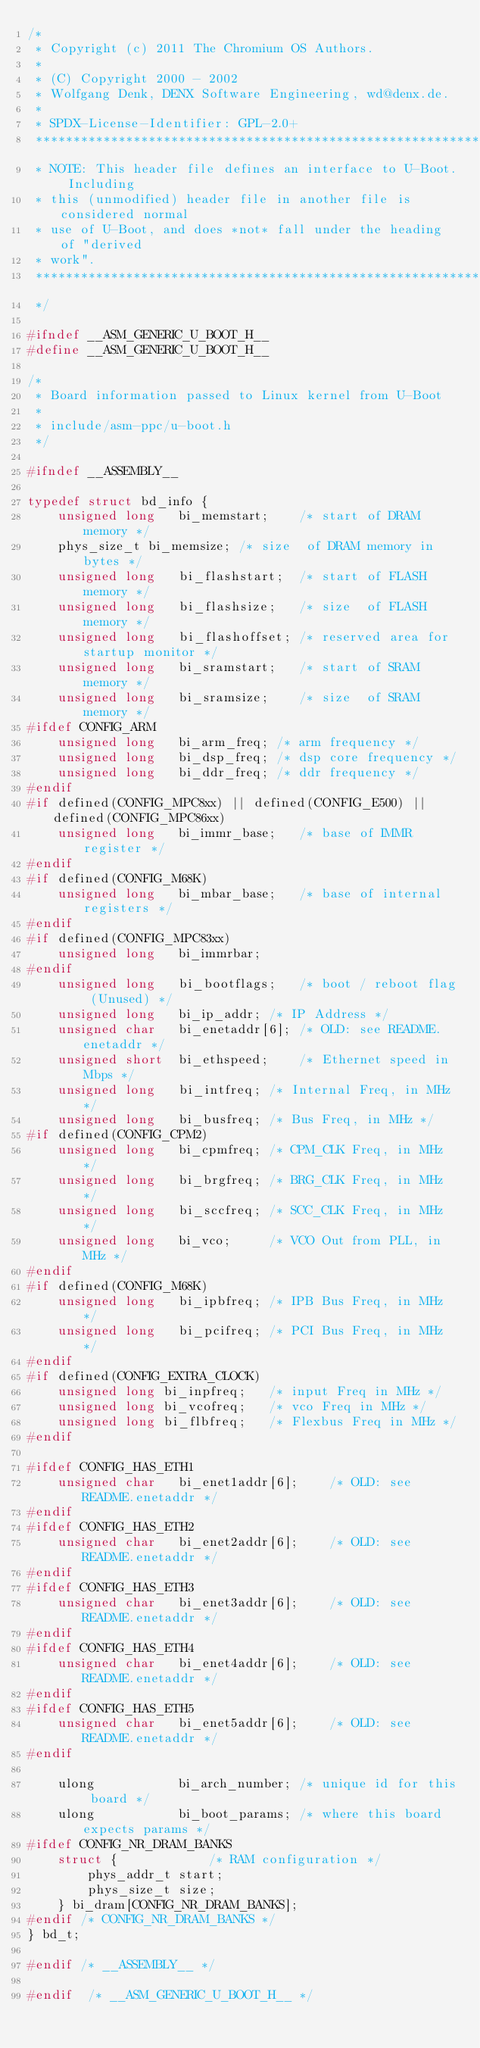<code> <loc_0><loc_0><loc_500><loc_500><_C_>/*
 * Copyright (c) 2011 The Chromium OS Authors.
 *
 * (C) Copyright 2000 - 2002
 * Wolfgang Denk, DENX Software Engineering, wd@denx.de.
 *
 * SPDX-License-Identifier:	GPL-2.0+
 ********************************************************************
 * NOTE: This header file defines an interface to U-Boot. Including
 * this (unmodified) header file in another file is considered normal
 * use of U-Boot, and does *not* fall under the heading of "derived
 * work".
 ********************************************************************
 */

#ifndef __ASM_GENERIC_U_BOOT_H__
#define __ASM_GENERIC_U_BOOT_H__

/*
 * Board information passed to Linux kernel from U-Boot
 *
 * include/asm-ppc/u-boot.h
 */

#ifndef __ASSEMBLY__

typedef struct bd_info {
	unsigned long	bi_memstart;	/* start of DRAM memory */
	phys_size_t	bi_memsize;	/* size	 of DRAM memory in bytes */
	unsigned long	bi_flashstart;	/* start of FLASH memory */
	unsigned long	bi_flashsize;	/* size	 of FLASH memory */
	unsigned long	bi_flashoffset; /* reserved area for startup monitor */
	unsigned long	bi_sramstart;	/* start of SRAM memory */
	unsigned long	bi_sramsize;	/* size	 of SRAM memory */
#ifdef CONFIG_ARM
	unsigned long	bi_arm_freq; /* arm frequency */
	unsigned long	bi_dsp_freq; /* dsp core frequency */
	unsigned long	bi_ddr_freq; /* ddr frequency */
#endif
#if defined(CONFIG_MPC8xx) || defined(CONFIG_E500) || defined(CONFIG_MPC86xx)
	unsigned long	bi_immr_base;	/* base of IMMR register */
#endif
#if defined(CONFIG_M68K)
	unsigned long	bi_mbar_base;	/* base of internal registers */
#endif
#if defined(CONFIG_MPC83xx)
	unsigned long	bi_immrbar;
#endif
	unsigned long	bi_bootflags;	/* boot / reboot flag (Unused) */
	unsigned long	bi_ip_addr;	/* IP Address */
	unsigned char	bi_enetaddr[6];	/* OLD: see README.enetaddr */
	unsigned short	bi_ethspeed;	/* Ethernet speed in Mbps */
	unsigned long	bi_intfreq;	/* Internal Freq, in MHz */
	unsigned long	bi_busfreq;	/* Bus Freq, in MHz */
#if defined(CONFIG_CPM2)
	unsigned long	bi_cpmfreq;	/* CPM_CLK Freq, in MHz */
	unsigned long	bi_brgfreq;	/* BRG_CLK Freq, in MHz */
	unsigned long	bi_sccfreq;	/* SCC_CLK Freq, in MHz */
	unsigned long	bi_vco;		/* VCO Out from PLL, in MHz */
#endif
#if defined(CONFIG_M68K)
	unsigned long	bi_ipbfreq;	/* IPB Bus Freq, in MHz */
	unsigned long	bi_pcifreq;	/* PCI Bus Freq, in MHz */
#endif
#if defined(CONFIG_EXTRA_CLOCK)
	unsigned long bi_inpfreq;	/* input Freq in MHz */
	unsigned long bi_vcofreq;	/* vco Freq in MHz */
	unsigned long bi_flbfreq;	/* Flexbus Freq in MHz */
#endif

#ifdef CONFIG_HAS_ETH1
	unsigned char   bi_enet1addr[6];	/* OLD: see README.enetaddr */
#endif
#ifdef CONFIG_HAS_ETH2
	unsigned char	bi_enet2addr[6];	/* OLD: see README.enetaddr */
#endif
#ifdef CONFIG_HAS_ETH3
	unsigned char   bi_enet3addr[6];	/* OLD: see README.enetaddr */
#endif
#ifdef CONFIG_HAS_ETH4
	unsigned char   bi_enet4addr[6];	/* OLD: see README.enetaddr */
#endif
#ifdef CONFIG_HAS_ETH5
	unsigned char   bi_enet5addr[6];	/* OLD: see README.enetaddr */
#endif

	ulong	        bi_arch_number;	/* unique id for this board */
	ulong	        bi_boot_params;	/* where this board expects params */
#ifdef CONFIG_NR_DRAM_BANKS
	struct {			/* RAM configuration */
		phys_addr_t start;
		phys_size_t size;
	} bi_dram[CONFIG_NR_DRAM_BANKS];
#endif /* CONFIG_NR_DRAM_BANKS */
} bd_t;

#endif /* __ASSEMBLY__ */

#endif	/* __ASM_GENERIC_U_BOOT_H__ */
</code> 